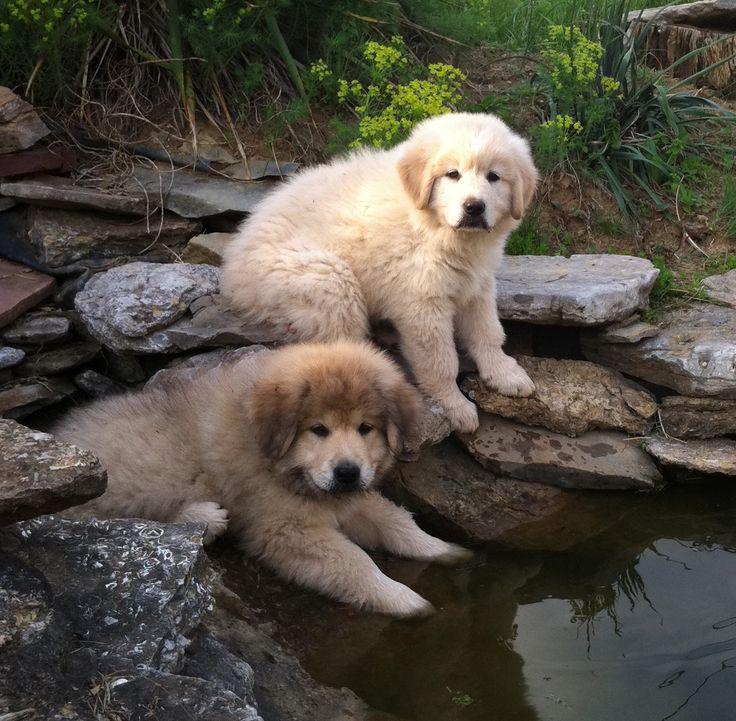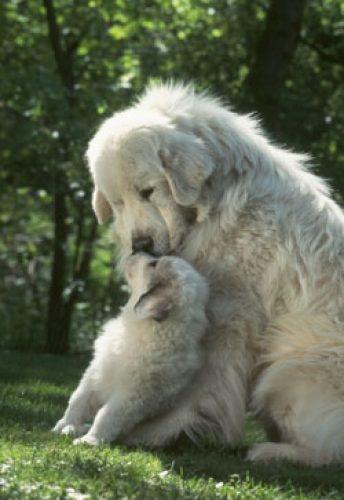The first image is the image on the left, the second image is the image on the right. Examine the images to the left and right. Is the description "the right pic has two or more dogs" accurate? Answer yes or no. Yes. The first image is the image on the left, the second image is the image on the right. Analyze the images presented: Is the assertion "In at least one image there are exactly two dogs that are seated close together." valid? Answer yes or no. Yes. 